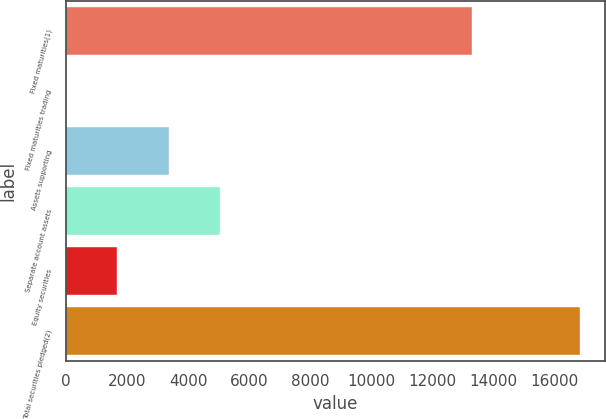<chart> <loc_0><loc_0><loc_500><loc_500><bar_chart><fcel>Fixed maturities(1)<fcel>Fixed maturities trading<fcel>Assets supporting<fcel>Separate account assets<fcel>Equity securities<fcel>Total securities pledged(2)<nl><fcel>13303<fcel>2.53<fcel>3369.23<fcel>5052.58<fcel>1685.88<fcel>16836<nl></chart> 